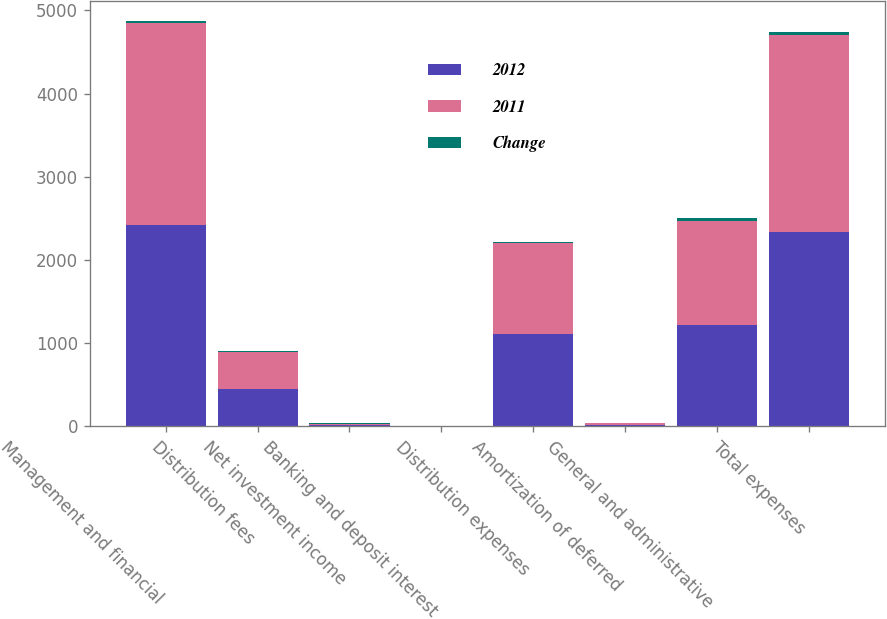Convert chart. <chart><loc_0><loc_0><loc_500><loc_500><stacked_bar_chart><ecel><fcel>Management and financial<fcel>Distribution fees<fcel>Net investment income<fcel>Banking and deposit interest<fcel>Distribution expenses<fcel>Amortization of deferred<fcel>General and administrative<fcel>Total expenses<nl><fcel>2012<fcel>2420<fcel>442<fcel>19<fcel>2<fcel>1105<fcel>16<fcel>1213<fcel>2334<nl><fcel>2011<fcel>2434<fcel>450<fcel>11<fcel>3<fcel>1095<fcel>19<fcel>1255<fcel>2369<nl><fcel>Change<fcel>14<fcel>8<fcel>8<fcel>1<fcel>10<fcel>3<fcel>42<fcel>35<nl></chart> 